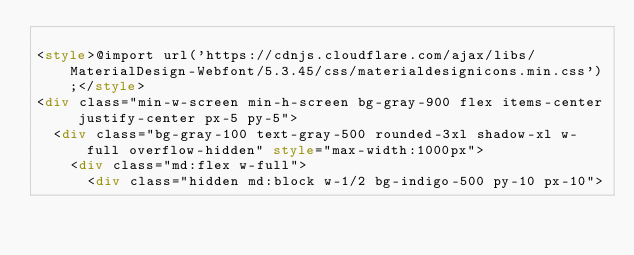<code> <loc_0><loc_0><loc_500><loc_500><_HTML_>
<style>@import url('https://cdnjs.cloudflare.com/ajax/libs/MaterialDesign-Webfont/5.3.45/css/materialdesignicons.min.css');</style>
<div class="min-w-screen min-h-screen bg-gray-900 flex items-center justify-center px-5 py-5">
  <div class="bg-gray-100 text-gray-500 rounded-3xl shadow-xl w-full overflow-hidden" style="max-width:1000px">
    <div class="md:flex w-full">
      <div class="hidden md:block w-1/2 bg-indigo-500 py-10 px-10"></code> 